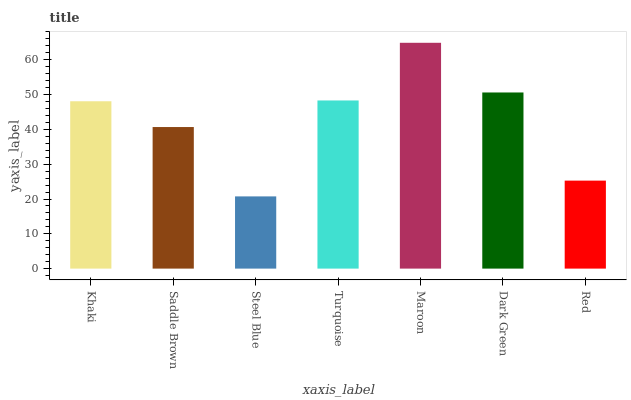Is Steel Blue the minimum?
Answer yes or no. Yes. Is Maroon the maximum?
Answer yes or no. Yes. Is Saddle Brown the minimum?
Answer yes or no. No. Is Saddle Brown the maximum?
Answer yes or no. No. Is Khaki greater than Saddle Brown?
Answer yes or no. Yes. Is Saddle Brown less than Khaki?
Answer yes or no. Yes. Is Saddle Brown greater than Khaki?
Answer yes or no. No. Is Khaki less than Saddle Brown?
Answer yes or no. No. Is Khaki the high median?
Answer yes or no. Yes. Is Khaki the low median?
Answer yes or no. Yes. Is Dark Green the high median?
Answer yes or no. No. Is Saddle Brown the low median?
Answer yes or no. No. 